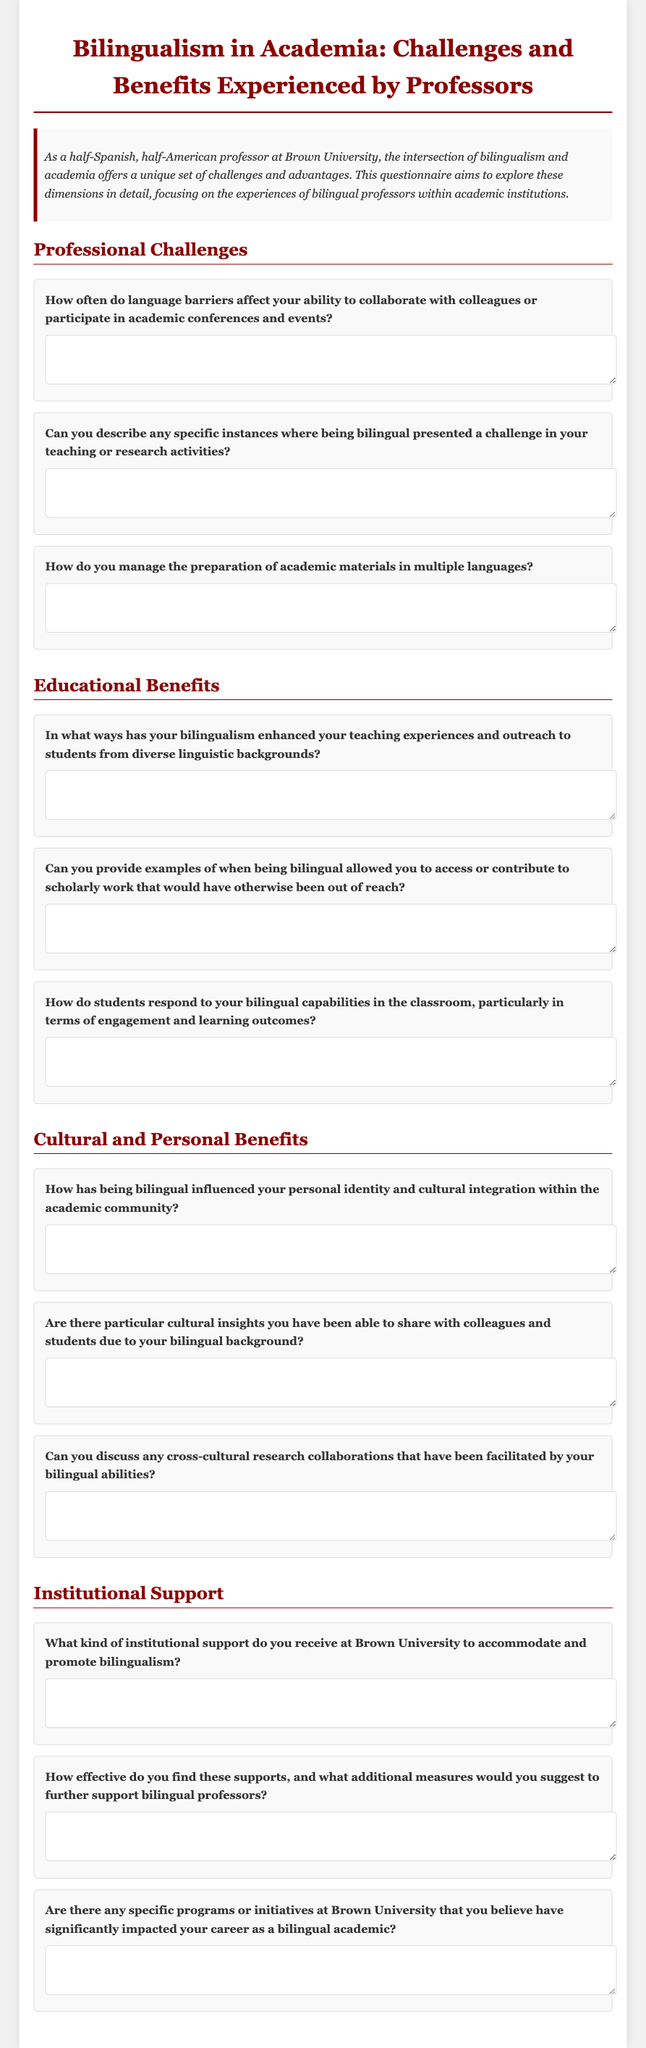What is the title of the questionnaire? The title is prominently displayed at the top of the document and reads "Bilingualism in Academia: Challenges and Benefits Experienced by Professors."
Answer: Bilingualism in Academia: Challenges and Benefits Experienced by Professors What university is mentioned in the document? The document states the name of the academic institution where the questionnaire is conducted, which is Brown University.
Answer: Brown University How many sections are included in the questionnaire? The document outlines four distinct sections of questions, providing a structured approach to the questionnaire.
Answer: Four What color is used for the section headers? The section headers are styled in a specific color that is consistently applied throughout the document.
Answer: Dark Red What type of questions primarily constitute the questionnaire? The nature of the questions is described in the introduction, focusing on the experiences of bilingual professors.
Answer: Short-answer questions How does the introduction describe the professor's background? The introduction provides a brief insight into the professor's unique cultural and personal background, highlighting their bilingualism.
Answer: Half-Spanish, half-American What does the document request feedback on? Throughout the document, there is a clear emphasis on collecting feedback from bilingual professors regarding their experiences and perspectives.
Answer: Experiences and perspectives What is one of the professional challenges discussed? The document includes a question explicitly asking about challenges faced, such as language barriers.
Answer: Language barriers What aspect of education does the questionnaire emphasize? The educational part focuses on the benefits of bilingualism in enhancing teaching and engagement with students.
Answer: Enhancement of teaching experiences 